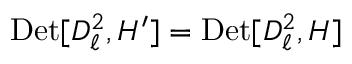<formula> <loc_0><loc_0><loc_500><loc_500>D e t [ D _ { \ell } ^ { 2 } , H ^ { \prime } ] = D e t [ D _ { \ell } ^ { 2 } , H ]</formula> 